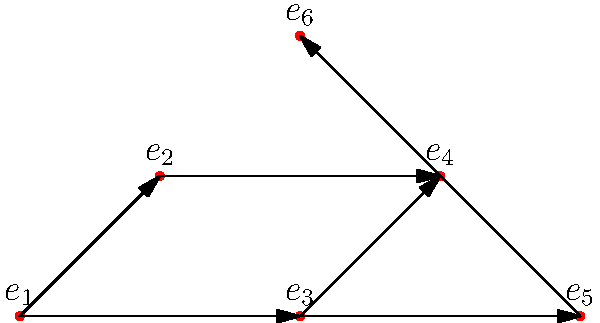As the synagogue president organizing a Jewish cultural festival, you're tasked with scheduling events. The directed graph represents the order in which events must occur. Vertices represent events, and edges indicate that one event must precede another. What is the minimum number of time slots needed to schedule all events while respecting the precedence constraints? To solve this problem, we need to find the longest path in the directed acyclic graph (DAG), also known as the critical path. This path represents the minimum number of time slots required to schedule all events while respecting the precedence constraints.

Step 1: Identify all paths in the graph.
- $e_1 \rightarrow e_2 \rightarrow e_4 \rightarrow e_6$
- $e_1 \rightarrow e_3 \rightarrow e_4 \rightarrow e_6$
- $e_1 \rightarrow e_3 \rightarrow e_5 \rightarrow e_6$

Step 2: Count the number of vertices in each path.
- Path 1: 4 vertices
- Path 2: 4 vertices
- Path 3: 4 vertices

Step 3: Determine the longest path.
All paths have the same length of 4 vertices.

Step 4: Calculate the number of time slots needed.
The number of time slots required is equal to the number of vertices in the longest path. In this case, it's 4.

Therefore, the minimum number of time slots needed to schedule all events while respecting the precedence constraints is 4.
Answer: 4 time slots 